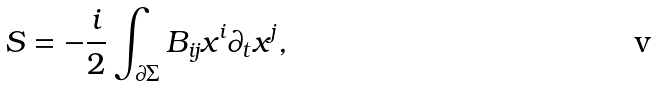Convert formula to latex. <formula><loc_0><loc_0><loc_500><loc_500>S = - \frac { i } { 2 } \int _ { \partial \Sigma } B _ { i j } x ^ { i } \partial _ { t } x ^ { j } ,</formula> 